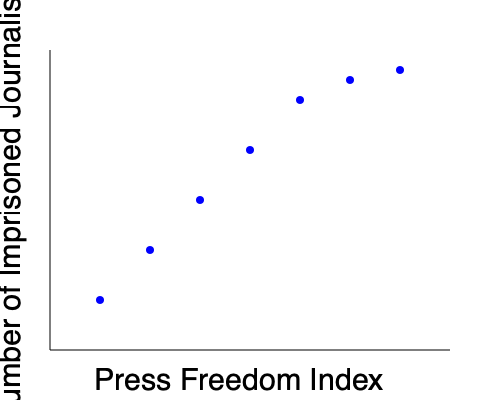As a diplomat working to secure the release of journalists, you are analyzing the relationship between press freedom and journalist imprisonment. Based on the scatter plot showing the correlation between the Press Freedom Index (x-axis) and the Number of Imprisoned Journalists (y-axis), what type of correlation is observed, and how might this information inform your diplomatic strategy? To answer this question, let's analyze the scatter plot step-by-step:

1. Observe the overall trend: As we move from left to right (increasing Press Freedom Index), the points generally move downward (decreasing Number of Imprisoned Journalists).

2. Identify the correlation type: This pattern indicates a negative correlation between the Press Freedom Index and the Number of Imprisoned Journalists.

3. Assess the strength of the correlation: The points follow a fairly consistent downward trend, suggesting a strong negative correlation.

4. Interpret the relationship: Countries with higher Press Freedom Index scores tend to have fewer imprisoned journalists, while countries with lower scores tend to have more.

5. Consider the implications for diplomatic strategy:
   a) Focus efforts on countries with low Press Freedom Index scores, as they are more likely to have a higher number of imprisoned journalists.
   b) Use the correlation as evidence when advocating for press freedom, arguing that improved press freedom is associated with fewer imprisoned journalists.
   c) Develop tailored approaches for countries at different points on the spectrum, recognizing that the challenges and potential solutions may vary based on a country's position in the correlation.

6. Recognize limitations: While the correlation is strong, it's important to note that correlation does not imply causation. Other factors may influence both variables.

Given this analysis, a diplomatic strategy informed by this data would likely prioritize engaging with countries that have lower Press Freedom Index scores, using the correlation as a basis for discussions on the benefits of press freedom and the importance of releasing imprisoned journalists.
Answer: Strong negative correlation; prioritize efforts in countries with low press freedom scores. 